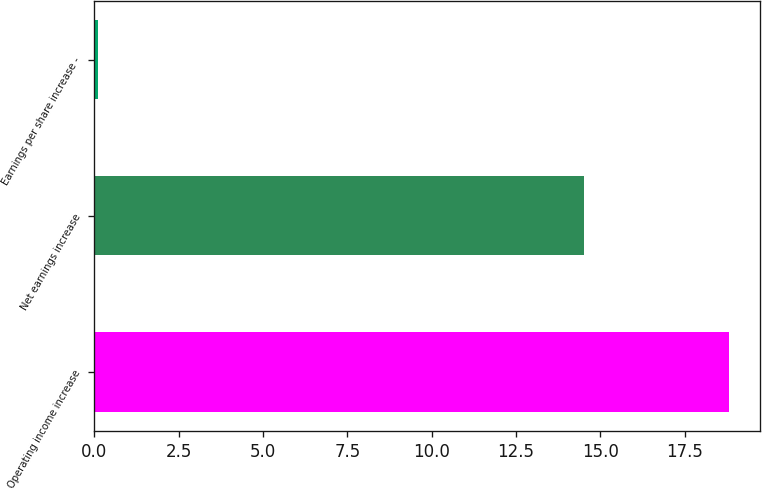Convert chart to OTSL. <chart><loc_0><loc_0><loc_500><loc_500><bar_chart><fcel>Operating income increase<fcel>Net earnings increase<fcel>Earnings per share increase -<nl><fcel>18.8<fcel>14.5<fcel>0.11<nl></chart> 